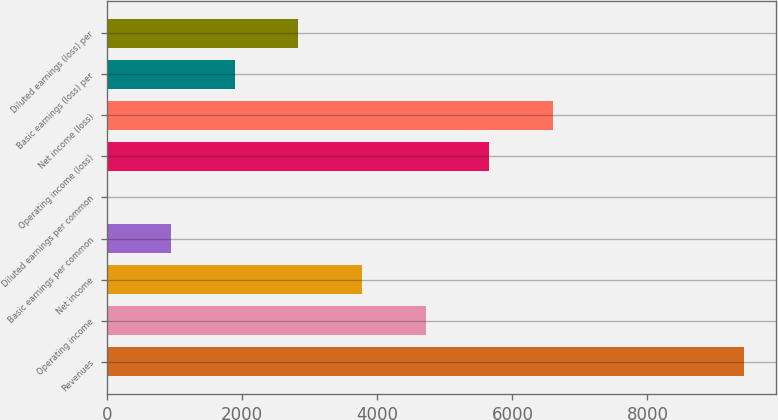Convert chart to OTSL. <chart><loc_0><loc_0><loc_500><loc_500><bar_chart><fcel>Revenues<fcel>Operating income<fcel>Net income<fcel>Basic earnings per common<fcel>Diluted earnings per common<fcel>Operating income (loss)<fcel>Net income (loss)<fcel>Basic earnings (loss) per<fcel>Diluted earnings (loss) per<nl><fcel>9428<fcel>4714.68<fcel>3772.01<fcel>944<fcel>1.33<fcel>5657.35<fcel>6600.02<fcel>1886.67<fcel>2829.34<nl></chart> 